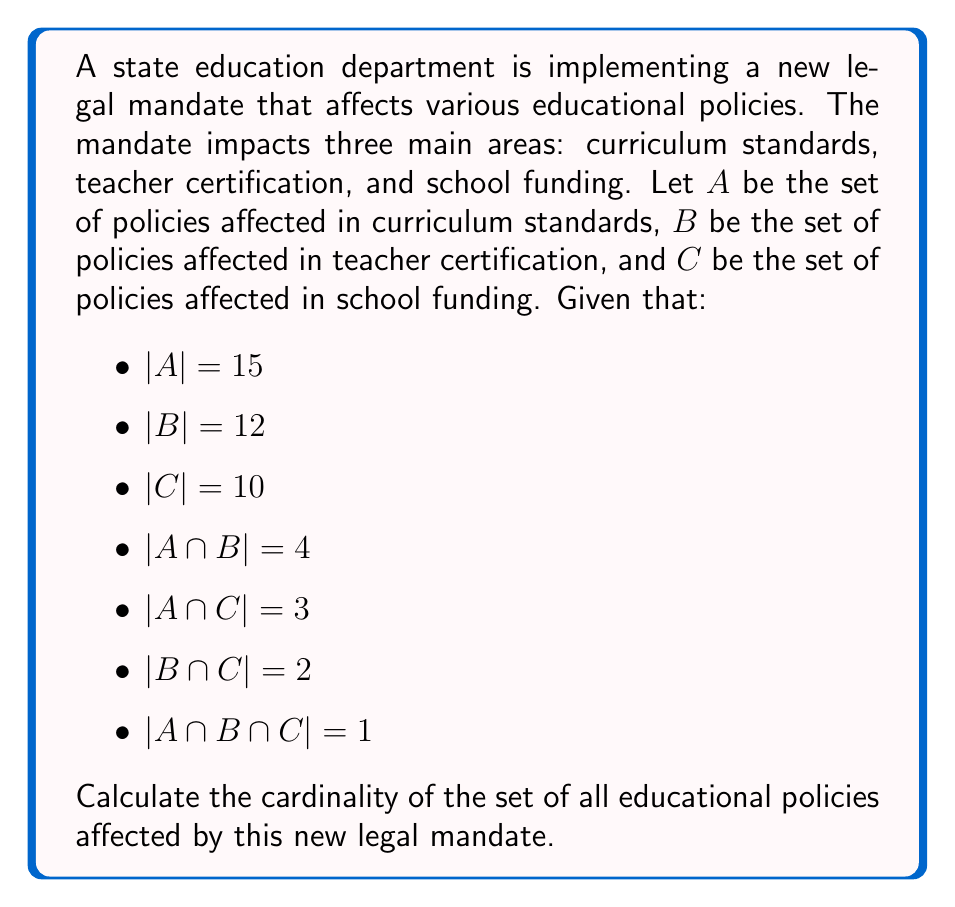Solve this math problem. To solve this problem, we need to use the principle of inclusion-exclusion for three sets. The formula for the cardinality of the union of three sets is:

$$|A \cup B \cup C| = |A| + |B| + |C| - |A \cap B| - |A \cap C| - |B \cap C| + |A \cap B \cap C|$$

Let's substitute the given values into this formula:

1) $|A| = 15$
2) $|B| = 12$
3) $|C| = 10$
4) $|A \cap B| = 4$
5) $|A \cap C| = 3$
6) $|B \cap C| = 2$
7) $|A \cap B \cap C| = 1$

Now, let's calculate:

$$\begin{align*}
|A \cup B \cup C| &= 15 + 12 + 10 - 4 - 3 - 2 + 1 \\
&= 37 - 9 + 1 \\
&= 29
\end{align*}$$

Therefore, the cardinality of the set of all educational policies affected by the new legal mandate is 29.
Answer: 29 